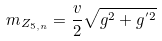Convert formula to latex. <formula><loc_0><loc_0><loc_500><loc_500>m _ { Z _ { 5 , n } } = \frac { v } { 2 } \sqrt { g ^ { 2 } + g ^ { ^ { \prime } 2 } }</formula> 